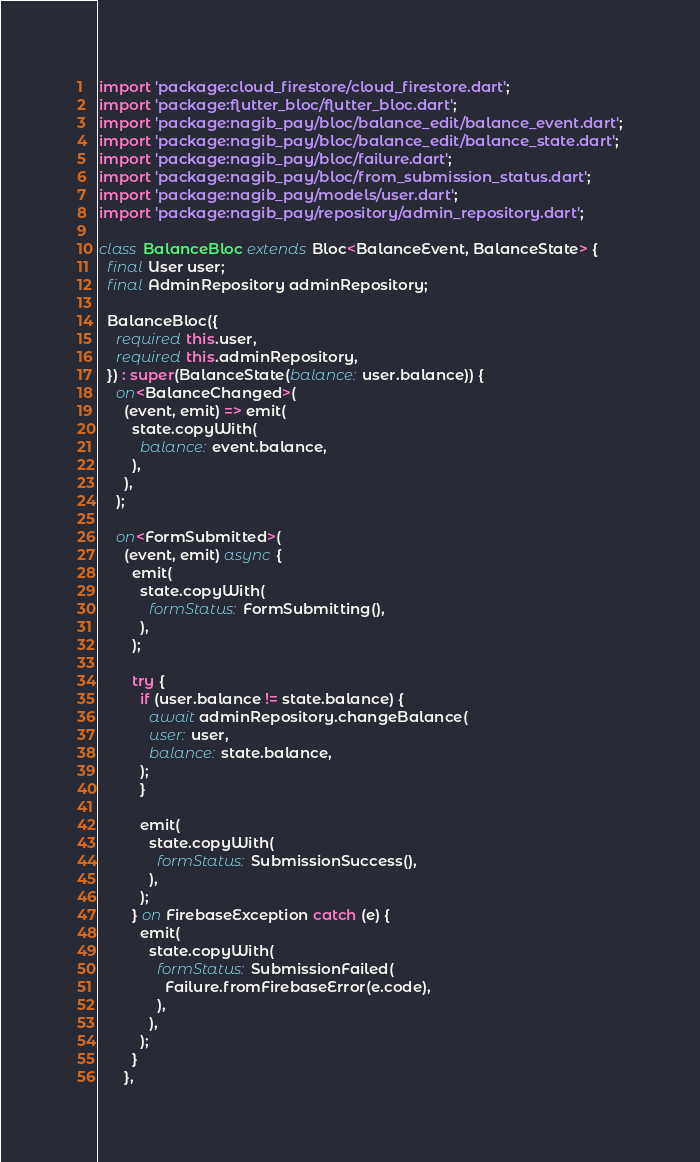Convert code to text. <code><loc_0><loc_0><loc_500><loc_500><_Dart_>import 'package:cloud_firestore/cloud_firestore.dart';
import 'package:flutter_bloc/flutter_bloc.dart';
import 'package:nagib_pay/bloc/balance_edit/balance_event.dart';
import 'package:nagib_pay/bloc/balance_edit/balance_state.dart';
import 'package:nagib_pay/bloc/failure.dart';
import 'package:nagib_pay/bloc/from_submission_status.dart';
import 'package:nagib_pay/models/user.dart';
import 'package:nagib_pay/repository/admin_repository.dart';

class BalanceBloc extends Bloc<BalanceEvent, BalanceState> {
  final User user;
  final AdminRepository adminRepository;

  BalanceBloc({
    required this.user,
    required this.adminRepository,
  }) : super(BalanceState(balance: user.balance)) {
    on<BalanceChanged>(
      (event, emit) => emit(
        state.copyWith(
          balance: event.balance,
        ),
      ),
    );

    on<FormSubmitted>(
      (event, emit) async {
        emit(
          state.copyWith(
            formStatus: FormSubmitting(),
          ),
        );

        try {
          if (user.balance != state.balance) {
            await adminRepository.changeBalance(
            user: user,
            balance: state.balance,
          );
          }

          emit(
            state.copyWith(
              formStatus: SubmissionSuccess(),
            ),
          );
        } on FirebaseException catch (e) {
          emit(
            state.copyWith(
              formStatus: SubmissionFailed(
                Failure.fromFirebaseError(e.code),
              ),
            ),
          );
        }
      },</code> 